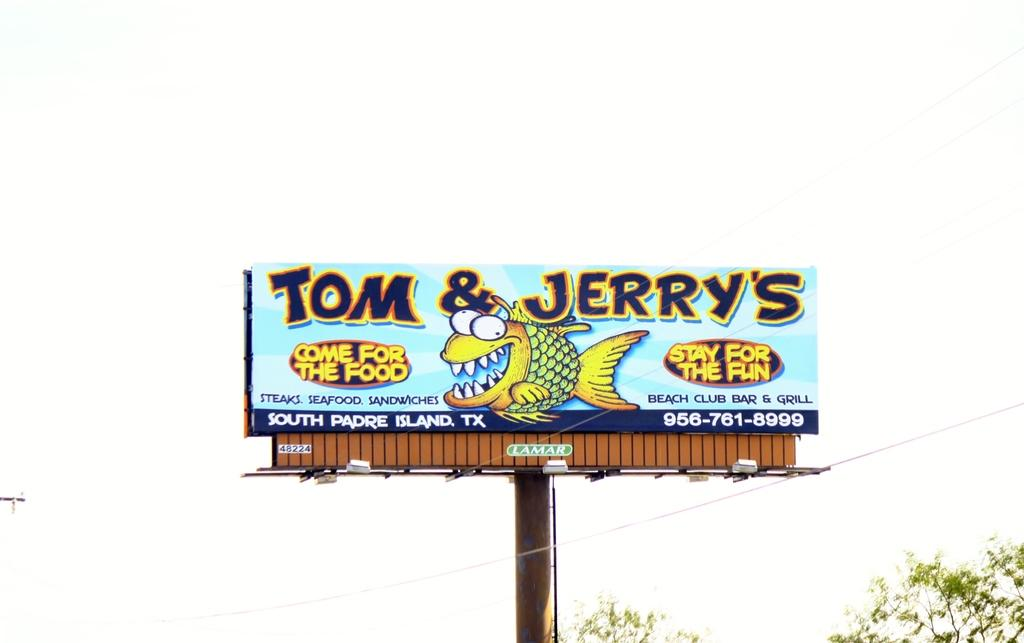Provide a one-sentence caption for the provided image. A billboard for Tom and Jerry's promises food and fun to its prospective patrons. 